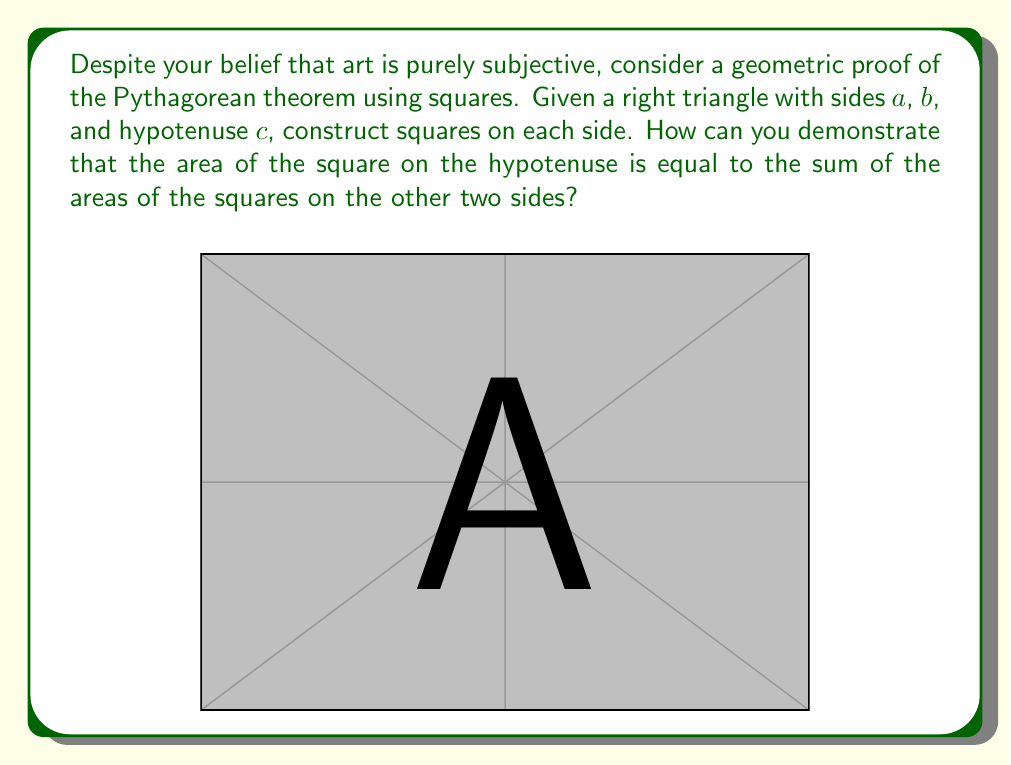What is the answer to this math problem? Let's approach this proof geometrically:

1) Start with a right triangle with sides $a$, $b$, and hypotenuse $c$.

2) Construct squares on each side of the triangle:
   - Square on side $a$ has area $a^2$
   - Square on side $b$ has area $b^2$
   - Square on hypotenuse $c$ has area $c^2$

3) Now, construct a larger square with side length $(a+b)$:
   
   [asy]
   unitsize(1cm);
   pair A=(0,0), B=(5,0), C=(5,5), D=(0,5);
   draw(A--B--C--D--cycle);
   draw((0,2)--(5,2));
   draw((3,0)--(3,5));
   label("$a$", (1.5,5.2));
   label("$b$", (4,5.2));
   label("$a$", (-0.2,1));
   label("$b$", (-0.2,3.5));
   [/asy]

4) The area of this larger square is $(a+b)^2$.

5) This larger square can be divided into four parts:
   - The square on the hypotenuse $c^2$
   - Two equal rectangles, each with area $ab$
   - A smaller square in the corner with area $(a-b)^2$

6) Therefore, we can write:
   $$(a+b)^2 = c^2 + 2ab + (a-b)^2$$

7) Expand the left side:
   $$a^2 + 2ab + b^2 = c^2 + 2ab + (a-b)^2$$

8) Cancel $2ab$ on both sides:
   $$a^2 + b^2 = c^2 + (a-b)^2$$

9) Expand $(a-b)^2$:
   $$a^2 + b^2 = c^2 + (a^2 - 2ab + b^2)$$

10) Cancel $a^2$ and $b^2$ on both sides:
    $$a^2 + b^2 = c^2$$

Thus, we have geometrically proven the Pythagorean theorem.
Answer: $a^2 + b^2 = c^2$ 